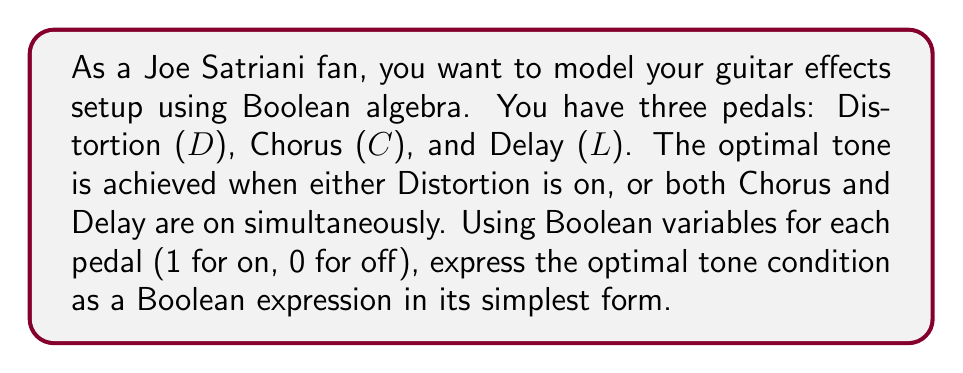Give your solution to this math problem. Let's approach this step-by-step:

1) We need to represent the optimal tone condition in Boolean terms. We have:
   - Distortion (D) on, OR
   - Both Chorus (C) and Delay (L) on simultaneously

2) In Boolean algebra, this can be written as:

   $$ D + (C \cdot L) $$

   Where '+' represents OR, and '·' represents AND.

3) This expression is already in its simplest form, as it cannot be reduced further using Boolean algebra laws.

4) To verify, we can create a truth table:

   $$
   \begin{array}{|c|c|c|c|}
   \hline
   D & C & L & D + (C \cdot L) \\
   \hline
   0 & 0 & 0 & 0 \\
   0 & 0 & 1 & 0 \\
   0 & 1 & 0 & 0 \\
   0 & 1 & 1 & 1 \\
   1 & 0 & 0 & 1 \\
   1 & 0 & 1 & 1 \\
   1 & 1 & 0 & 1 \\
   1 & 1 & 1 & 1 \\
   \hline
   \end{array}
   $$

5) The truth table confirms that the expression $D + (C \cdot L)$ accurately represents the desired conditions for optimal tone.
Answer: $D + (C \cdot L)$ 